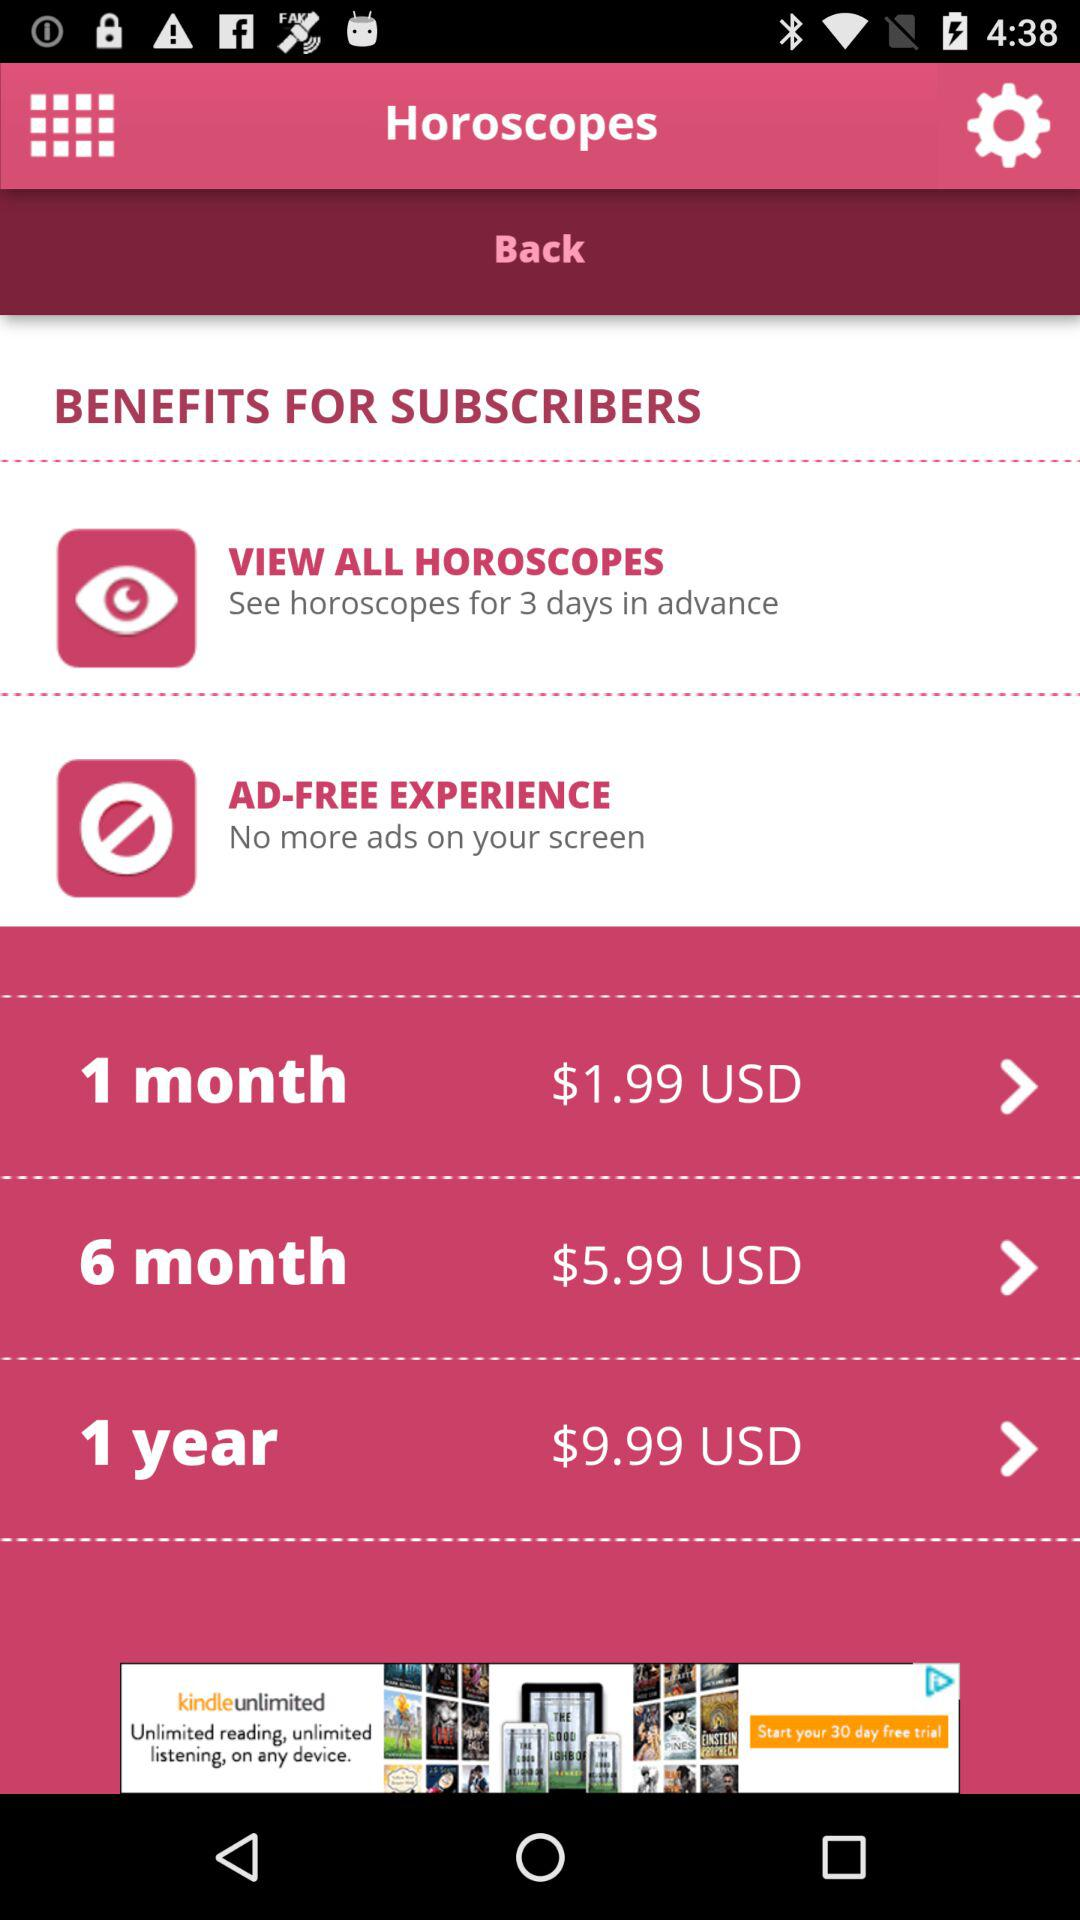What is the price of the 6-month plan? The price of the 6-month plan is $5.99 USD. 